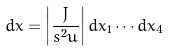Convert formula to latex. <formula><loc_0><loc_0><loc_500><loc_500>d x = \left | \frac { J } { s ^ { 2 } u } \right | d x _ { 1 } \cdots d x _ { 4 }</formula> 